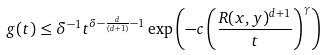<formula> <loc_0><loc_0><loc_500><loc_500>g ( t ) \leq \delta ^ { - 1 } t ^ { \delta - \frac { d } { ( d + 1 ) } - 1 } \exp \left ( - c \left ( \frac { R ( x , y ) ^ { d + 1 } } { t } \right ) ^ { \gamma } \right )</formula> 